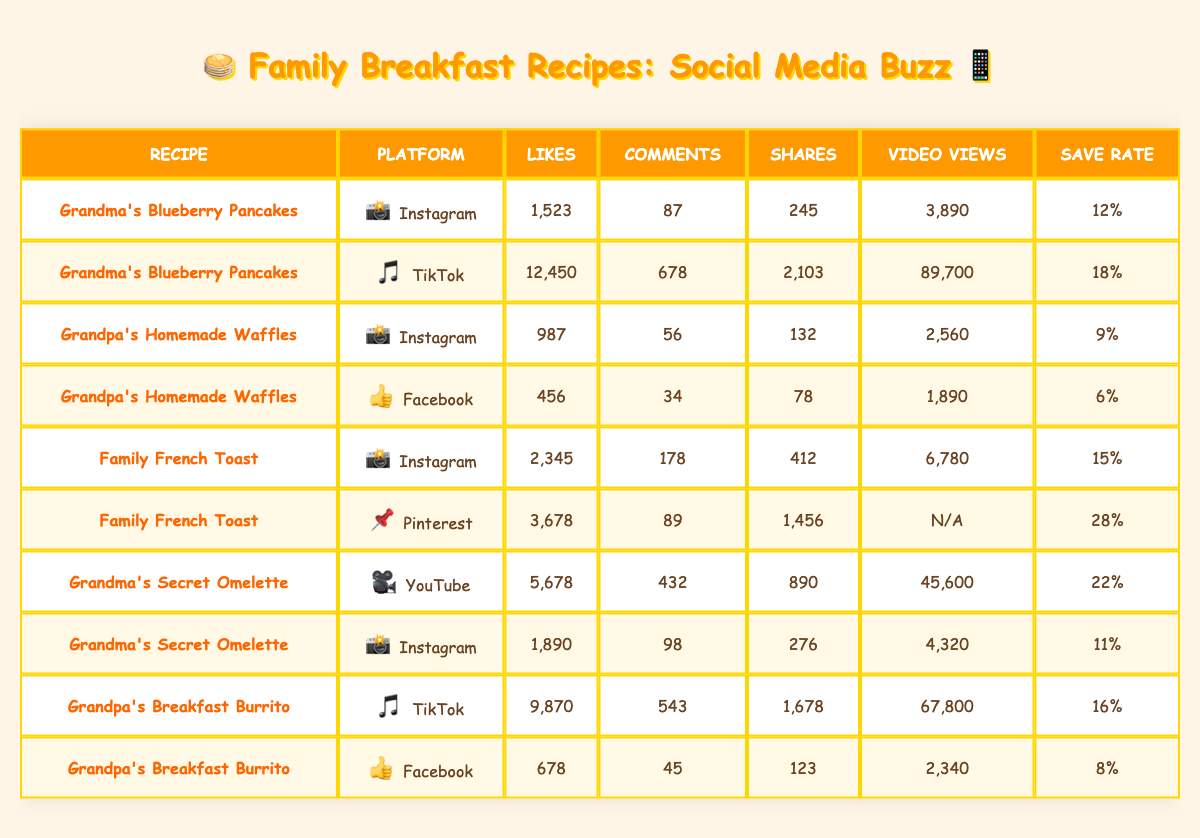What is the total number of likes for Grandma's Blueberry Pancakes across both platforms? To find the total number of likes for Grandma's Blueberry Pancakes, we add the likes from both Instagram and TikTok. On Instagram, it has 1,523 likes and on TikTok, it has 12,450 likes. So, 1,523 + 12,450 = 13,973.
Answer: 13,973 Which recipe received the most shares on Instagram? Checking the Instagram platform, the shares for each recipe are: Grandma's Blueberry Pancakes (245), Grandpa's Homemade Waffles (132), and Family French Toast (412). The highest number of shares is 412 for Family French Toast.
Answer: Family French Toast Is the save rate for Grandpa's Breakfast Burrito higher on TikTok or Facebook? For Grandpa's Breakfast Burrito, the save rate on TikTok is 16% and on Facebook is 8%. Comparing these two rates shows that 16% (TikTok) is higher than 8% (Facebook).
Answer: Yes What is the average number of comments across all recipes on Instagram? First, I will collect the comments from Instagram: Grandma's Blueberry Pancakes (87), Grandpa's Homemade Waffles (56), Family French Toast (178), Grandma's Secret Omelette (98). Adding these gives 87 + 56 + 178 + 98 = 419. There are four recipes, so the average is 419 / 4 = 104.75.
Answer: 104.75 Did Grandma's Secret Omelette have more video views on YouTube or Instagram? Grandma's Secret Omelette had 45,600 video views on YouTube and 4,320 on Instagram. Comparing these, it's clear that 45,600 (YouTube) is greater than 4,320 (Instagram).
Answer: Yes What is the total video views for all recipes on TikTok? The video views on TikTok for each recipe are: Grandma's Blueberry Pancakes (89,700) and Grandpa's Breakfast Burrito (67,800). Adding these together gives 89,700 + 67,800 = 157,500.
Answer: 157,500 Which family breakfast recipe has the highest save rate? The save rates for each recipe are as follows: Grandma's Blueberry Pancakes (12%), Grandpa's Homemade Waffles (9%), Family French Toast (15%), Grandma's Secret Omelette (22%), and Grandpa's Breakfast Burrito (16%). The highest rate is 22% for Grandma's Secret Omelette.
Answer: Grandma's Secret Omelette 